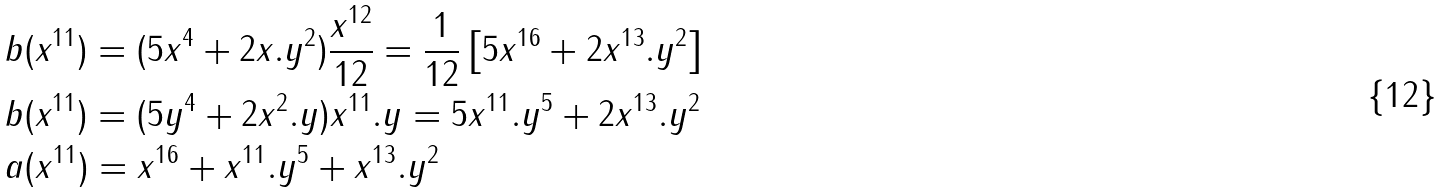<formula> <loc_0><loc_0><loc_500><loc_500>& b ( x ^ { 1 1 } ) = ( 5 x ^ { 4 } + 2 x . y ^ { 2 } ) \frac { x ^ { 1 2 } } { 1 2 } = \frac { 1 } { 1 2 } \left [ 5 x ^ { 1 6 } + 2 x ^ { 1 3 } . y ^ { 2 } \right ] \\ & b ( x ^ { 1 1 } ) = ( 5 y ^ { 4 } + 2 x ^ { 2 } . y ) x ^ { 1 1 } . y = 5 x ^ { 1 1 } . y ^ { 5 } + 2 x ^ { 1 3 } . y ^ { 2 } \\ & a ( x ^ { 1 1 } ) = x ^ { 1 6 } + x ^ { 1 1 } . y ^ { 5 } + x ^ { 1 3 } . y ^ { 2 }</formula> 